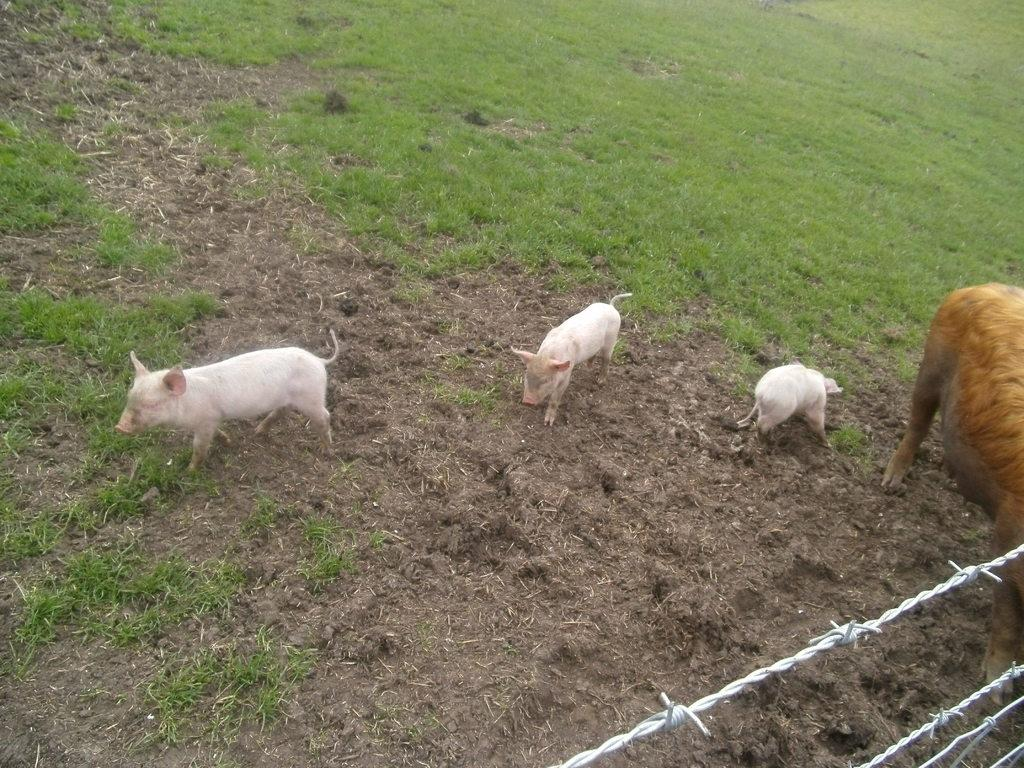What type of living organisms are present in the image? There are animals in the image. What colors can be seen on the animals? The animals are in white and brown color. What is the purpose of the structure visible in the image? There is fencing in the image, which is likely used to contain or separate the animals. What is the color of the grass in the background? The grass in the background is green. How many ornaments are hanging from the trees in the image? There are no ornaments present in the image; it features animals and fencing in a natural setting. Can you describe the chairs in the image? There are no chairs present in the image. 